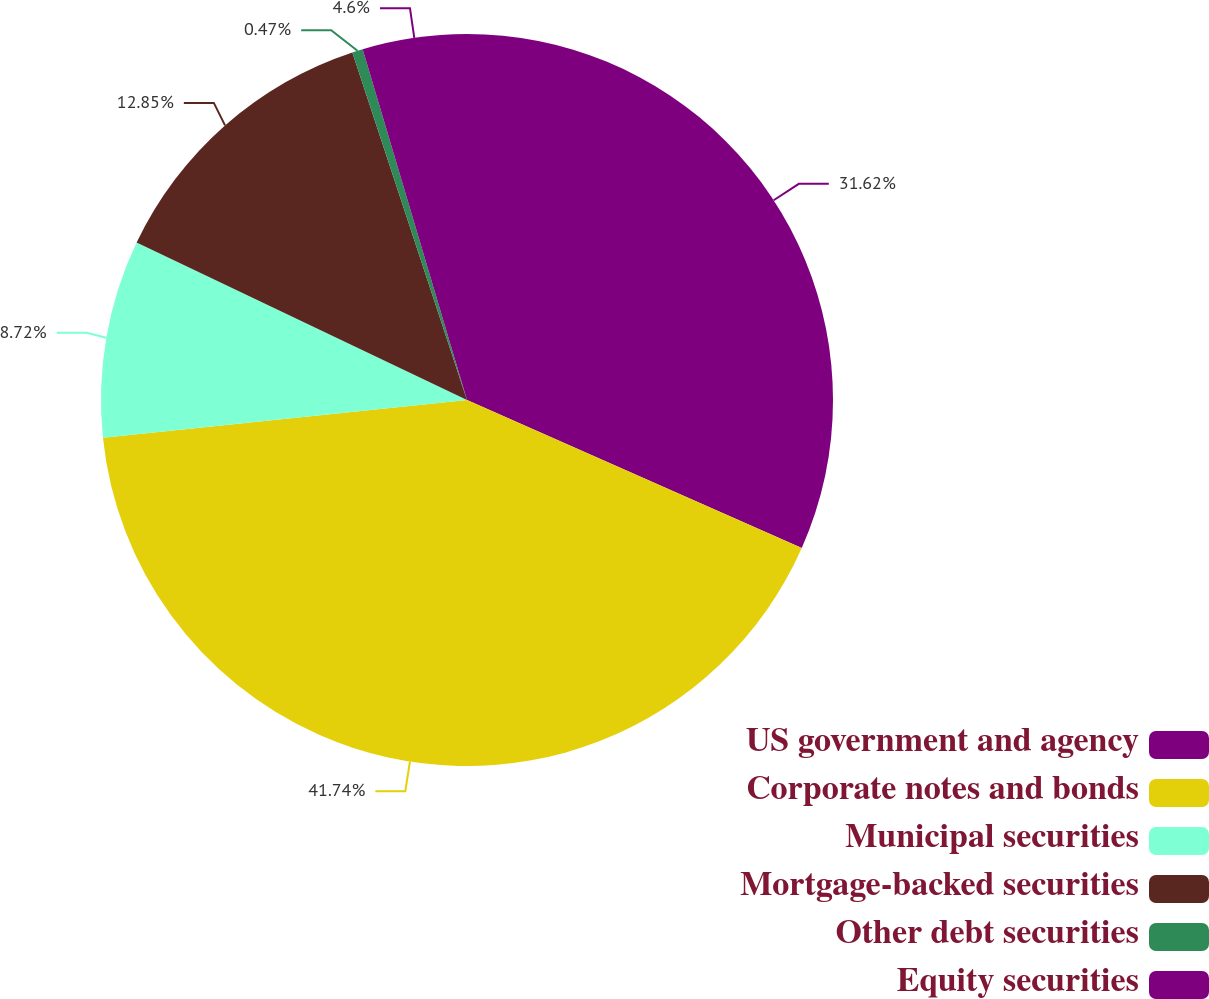<chart> <loc_0><loc_0><loc_500><loc_500><pie_chart><fcel>US government and agency<fcel>Corporate notes and bonds<fcel>Municipal securities<fcel>Mortgage-backed securities<fcel>Other debt securities<fcel>Equity securities<nl><fcel>31.62%<fcel>41.73%<fcel>8.72%<fcel>12.85%<fcel>0.47%<fcel>4.6%<nl></chart> 